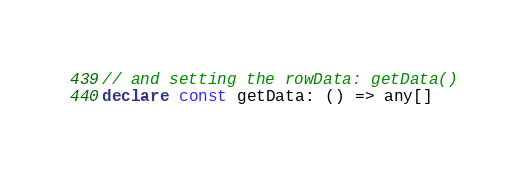Convert code to text. <code><loc_0><loc_0><loc_500><loc_500><_TypeScript_>// and setting the rowData: getData()
declare const getData: () => any[]
</code> 